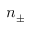<formula> <loc_0><loc_0><loc_500><loc_500>n _ { \pm }</formula> 